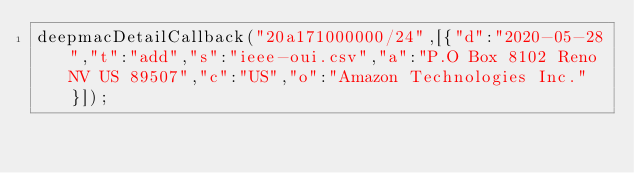<code> <loc_0><loc_0><loc_500><loc_500><_JavaScript_>deepmacDetailCallback("20a171000000/24",[{"d":"2020-05-28","t":"add","s":"ieee-oui.csv","a":"P.O Box 8102 Reno NV US 89507","c":"US","o":"Amazon Technologies Inc."}]);
</code> 